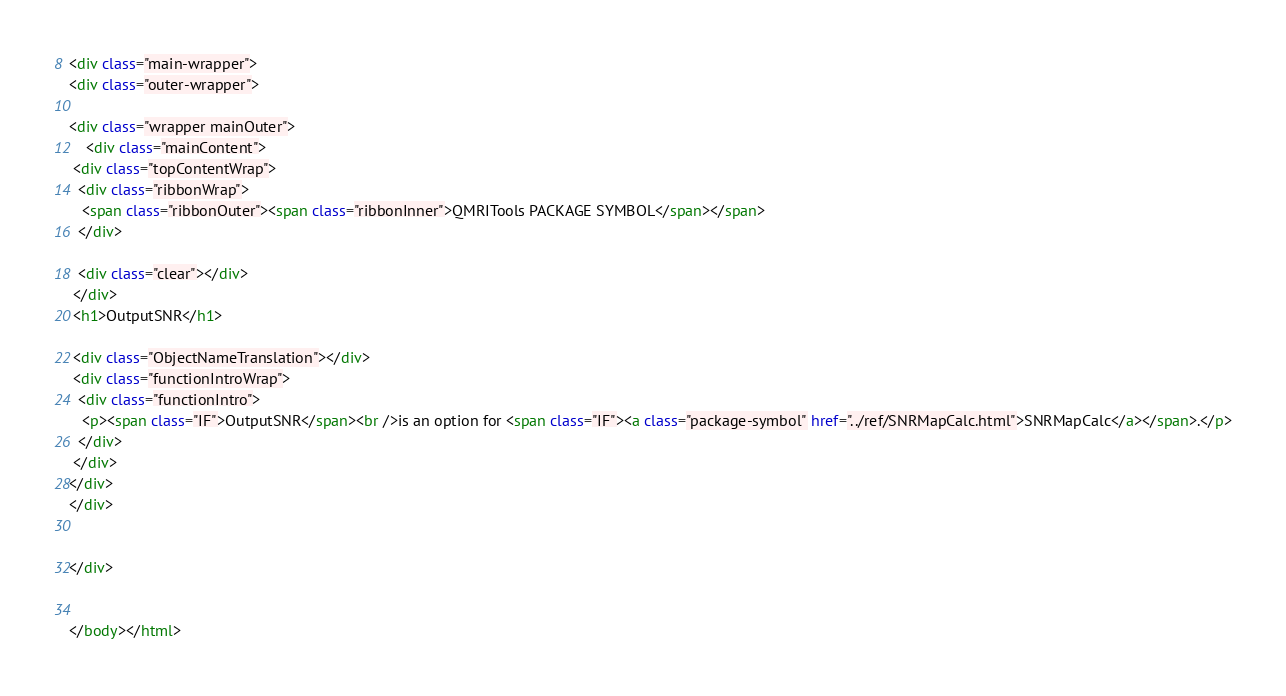<code> <loc_0><loc_0><loc_500><loc_500><_HTML_><div class="main-wrapper">
<div class="outer-wrapper">

<div class="wrapper mainOuter">
    <div class="mainContent">
 <div class="topContentWrap">
  <div class="ribbonWrap">
   <span class="ribbonOuter"><span class="ribbonInner">QMRITools PACKAGE SYMBOL</span></span>
  </div>
  
  <div class="clear"></div>
 </div>
 <h1>OutputSNR</h1>
 
 <div class="ObjectNameTranslation"></div>
 <div class="functionIntroWrap">
  <div class="functionIntro">
   <p><span class="IF">OutputSNR</span><br />is an option for <span class="IF"><a class="package-symbol" href="../ref/SNRMapCalc.html">SNRMapCalc</a></span>.</p>
  </div>
 </div>
</div>
</div>

	
</div>


</body></html></code> 